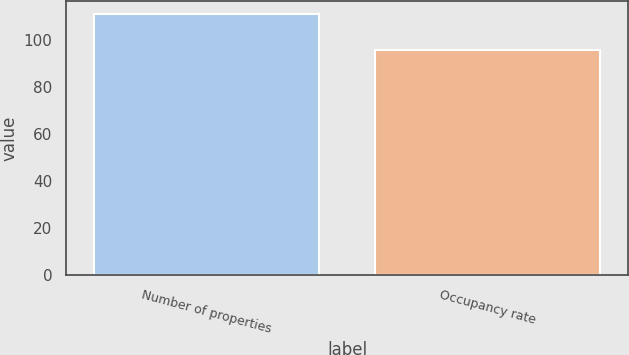Convert chart to OTSL. <chart><loc_0><loc_0><loc_500><loc_500><bar_chart><fcel>Number of properties<fcel>Occupancy rate<nl><fcel>111<fcel>95.6<nl></chart> 